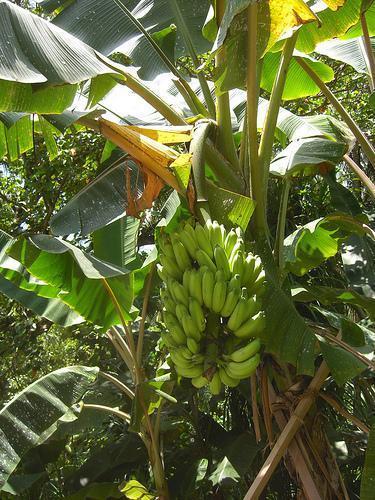How many complete green banana crop are in the picture?
Give a very brief answer. 1. 